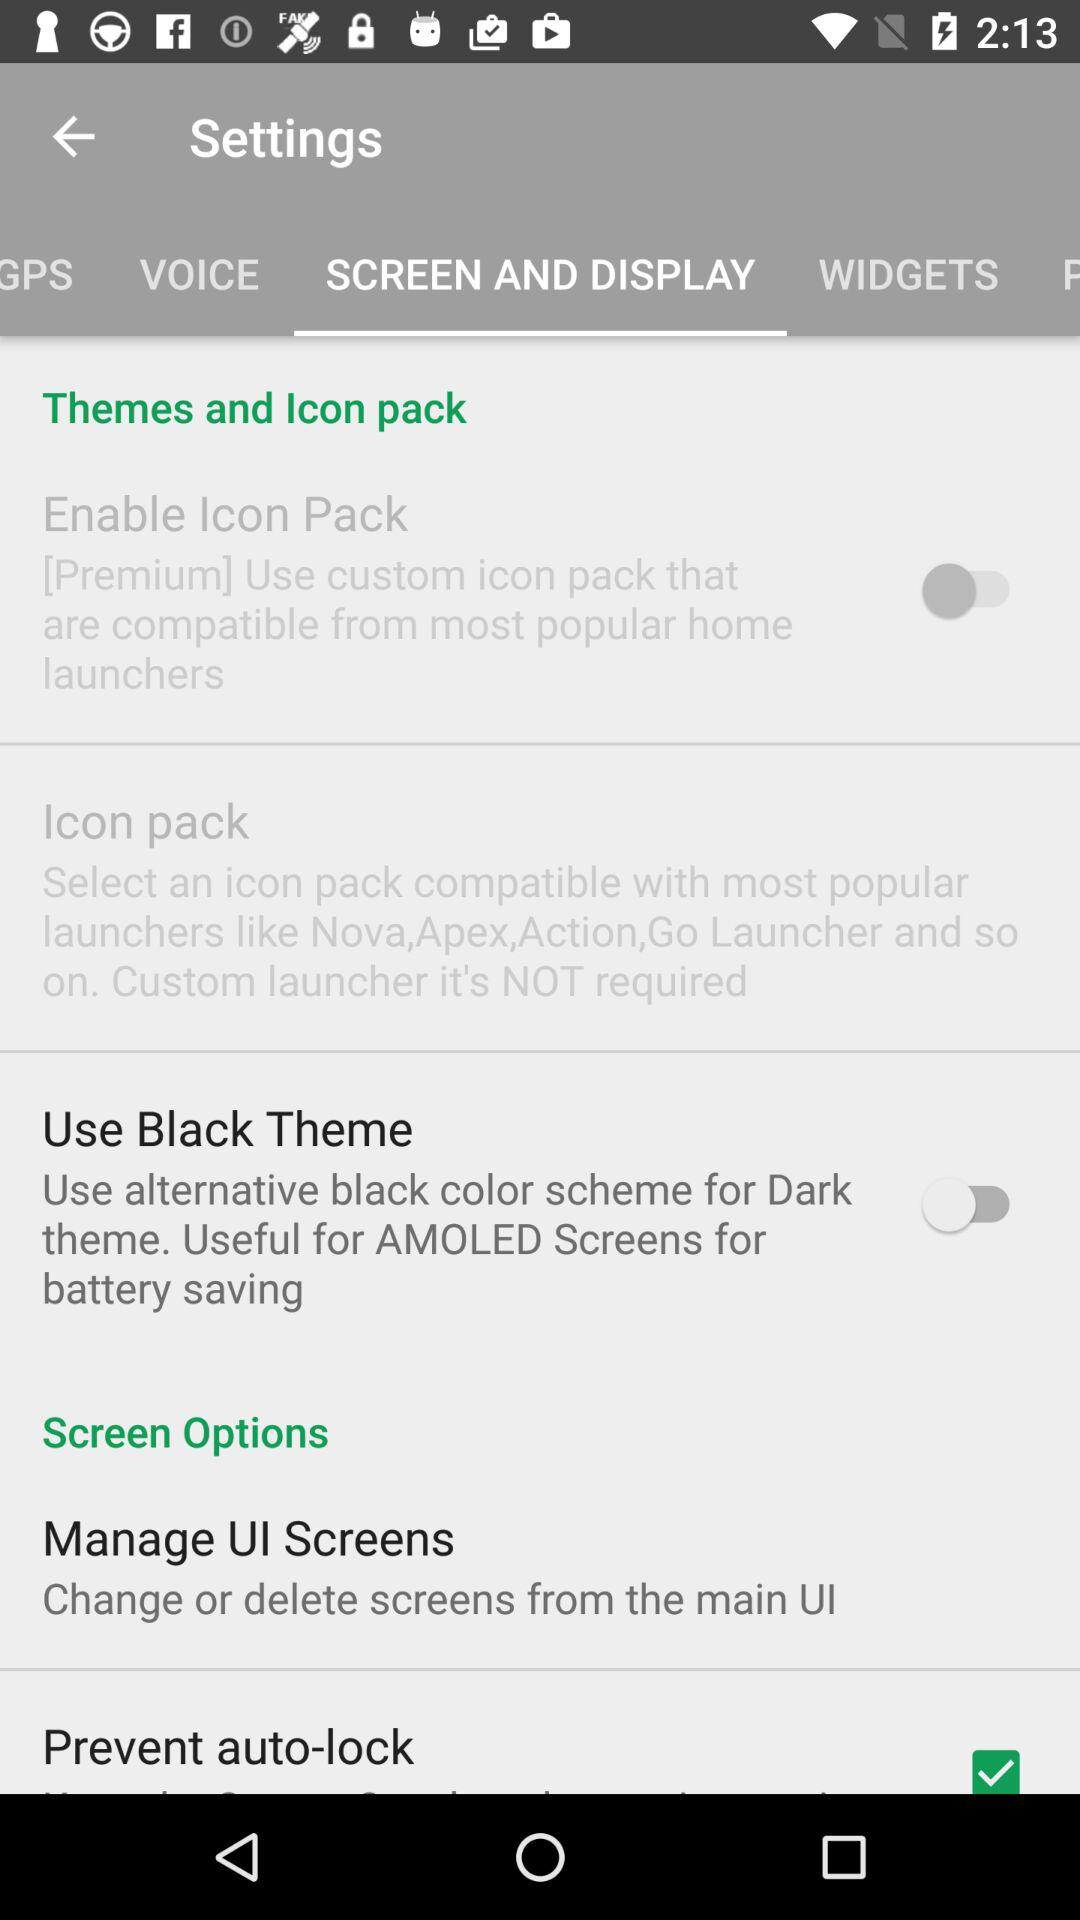Which tab is selected? The selected tab is "SCREEN AND DISPLAY". 